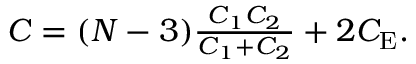<formula> <loc_0><loc_0><loc_500><loc_500>\begin{array} { r } { C = ( N - 3 ) \frac { C _ { 1 } C _ { 2 } } { C _ { 1 } + C _ { 2 } } + 2 C _ { E } . } \end{array}</formula> 